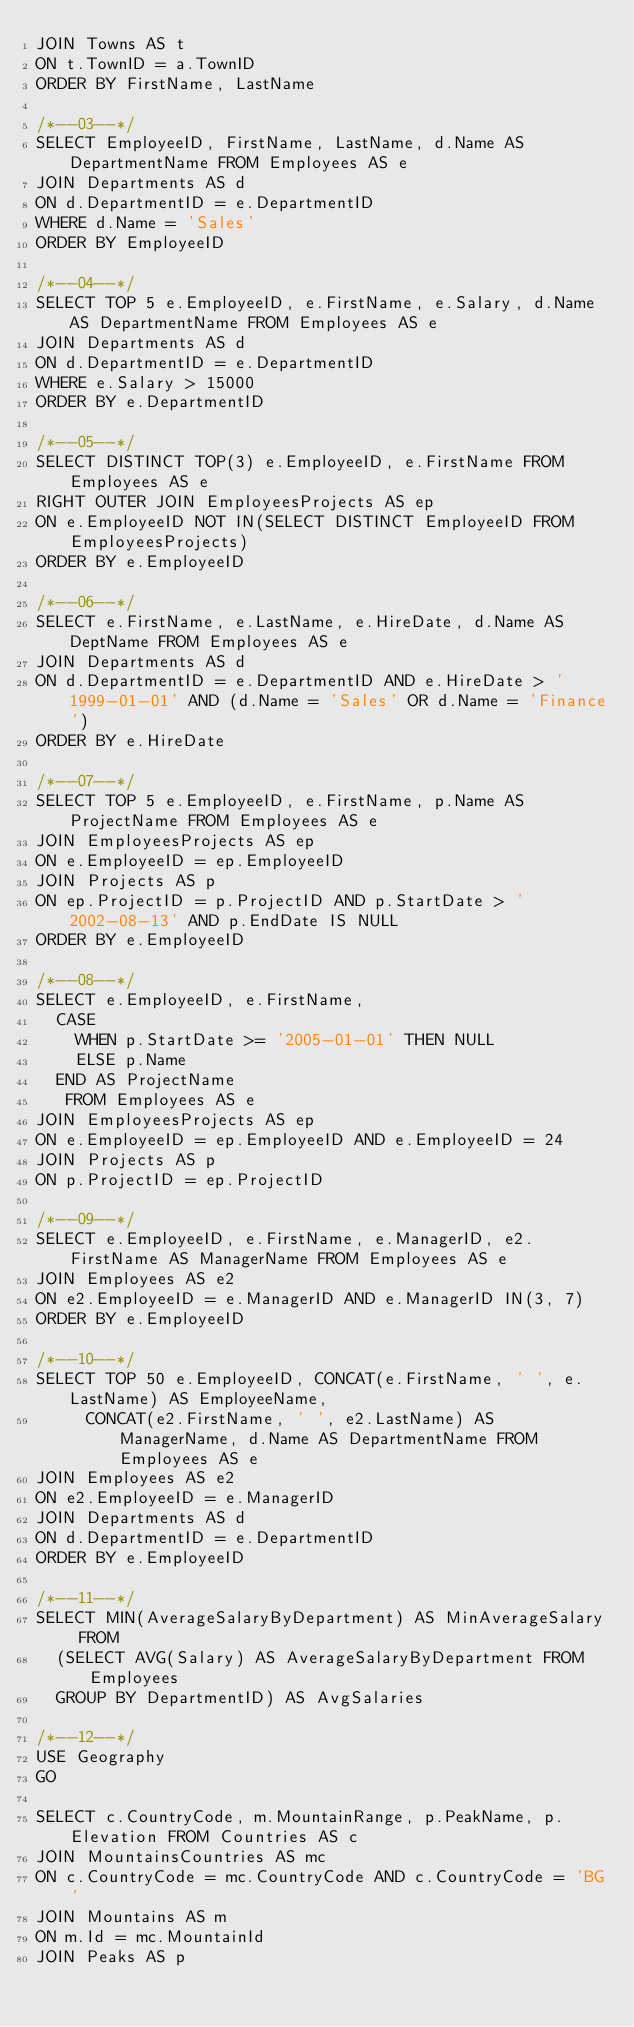Convert code to text. <code><loc_0><loc_0><loc_500><loc_500><_SQL_>JOIN Towns AS t
ON t.TownID = a.TownID
ORDER BY FirstName, LastName

/*--03--*/
SELECT EmployeeID, FirstName, LastName, d.Name AS DepartmentName FROM Employees AS e
JOIN Departments AS d
ON d.DepartmentID = e.DepartmentID
WHERE d.Name = 'Sales'
ORDER BY EmployeeID

/*--04--*/
SELECT TOP 5 e.EmployeeID, e.FirstName, e.Salary, d.Name AS DepartmentName FROM Employees AS e
JOIN Departments AS d
ON d.DepartmentID = e.DepartmentID
WHERE e.Salary > 15000
ORDER BY e.DepartmentID

/*--05--*/
SELECT DISTINCT TOP(3) e.EmployeeID, e.FirstName FROM Employees AS e
RIGHT OUTER JOIN EmployeesProjects AS ep
ON e.EmployeeID NOT IN(SELECT DISTINCT EmployeeID FROM EmployeesProjects)
ORDER BY e.EmployeeID

/*--06--*/
SELECT e.FirstName, e.LastName, e.HireDate, d.Name AS DeptName FROM Employees AS e
JOIN Departments AS d
ON d.DepartmentID = e.DepartmentID AND e.HireDate > '1999-01-01' AND (d.Name = 'Sales' OR d.Name = 'Finance')
ORDER BY e.HireDate

/*--07--*/
SELECT TOP 5 e.EmployeeID, e.FirstName, p.Name AS ProjectName FROM Employees AS e
JOIN EmployeesProjects AS ep
ON e.EmployeeID = ep.EmployeeID
JOIN Projects AS p
ON ep.ProjectID = p.ProjectID AND p.StartDate > '2002-08-13' AND p.EndDate IS NULL
ORDER BY e.EmployeeID

/*--08--*/
SELECT e.EmployeeID, e.FirstName,
	CASE
		WHEN p.StartDate >= '2005-01-01' THEN NULL
		ELSE p.Name
	END AS ProjectName
	 FROM Employees AS e
JOIN EmployeesProjects AS ep
ON e.EmployeeID = ep.EmployeeID AND e.EmployeeID = 24
JOIN Projects AS p
ON p.ProjectID = ep.ProjectID

/*--09--*/
SELECT e.EmployeeID, e.FirstName, e.ManagerID, e2.FirstName AS ManagerName FROM Employees AS e
JOIN Employees AS e2
ON e2.EmployeeID = e.ManagerID AND e.ManagerID IN(3, 7)
ORDER BY e.EmployeeID

/*--10--*/
SELECT TOP 50 e.EmployeeID, CONCAT(e.FirstName, ' ', e.LastName) AS EmployeeName,
	   CONCAT(e2.FirstName, ' ', e2.LastName) AS ManagerName, d.Name AS DepartmentName FROM Employees AS e
JOIN Employees AS e2
ON e2.EmployeeID = e.ManagerID
JOIN Departments AS d
ON d.DepartmentID = e.DepartmentID
ORDER BY e.EmployeeID

/*--11--*/
SELECT MIN(AverageSalaryByDepartment) AS MinAverageSalary FROM
	(SELECT AVG(Salary) AS AverageSalaryByDepartment FROM Employees
	GROUP BY DepartmentID) AS AvgSalaries

/*--12--*/
USE Geography
GO

SELECT c.CountryCode, m.MountainRange, p.PeakName, p.Elevation FROM Countries AS c
JOIN MountainsCountries AS mc
ON c.CountryCode = mc.CountryCode AND c.CountryCode = 'BG'
JOIN Mountains AS m
ON m.Id = mc.MountainId
JOIN Peaks AS p</code> 